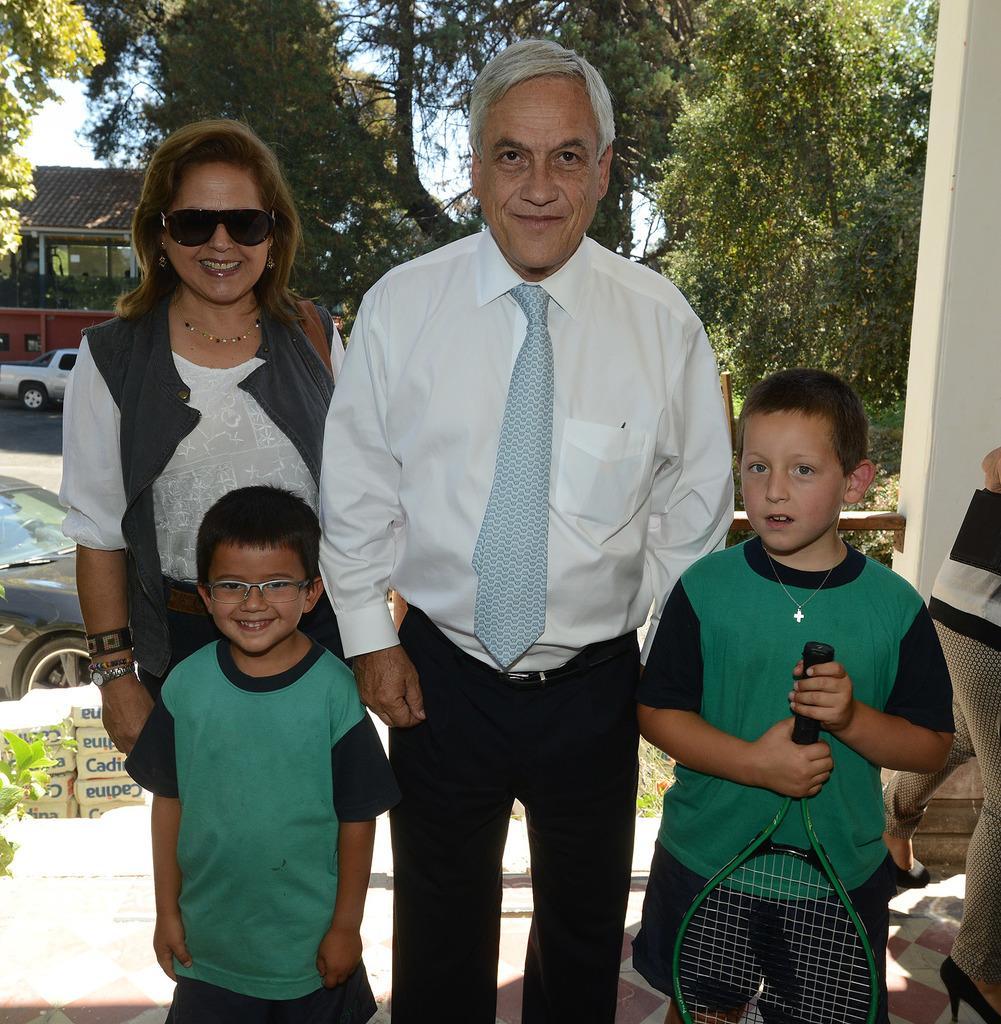Please provide a concise description of this image. In this image few people are standing. All of them are smiling. There are two kids in the image. the kid on the right is holding a racket. In the background there are building , trees, road, cars. 